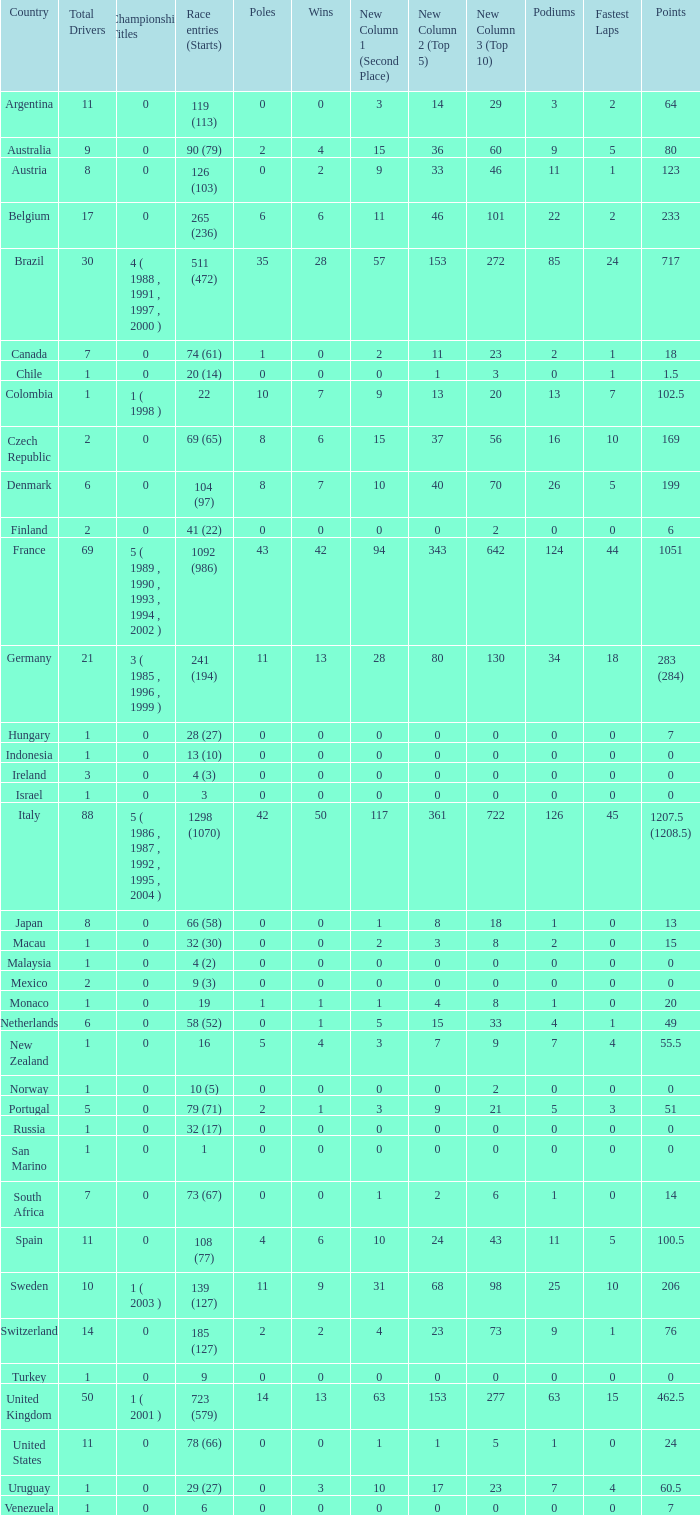How many fastest laps for the nation with 32 (30) entries and starts and fewer than 2 podiums? None. 